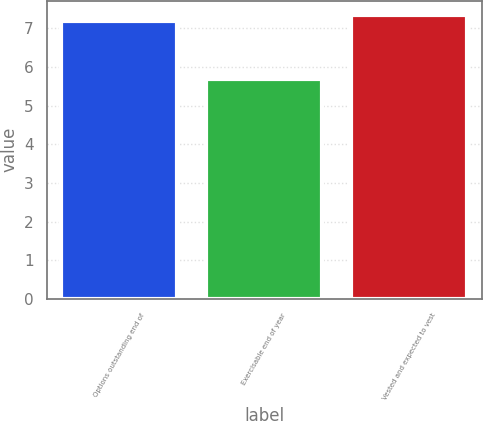Convert chart to OTSL. <chart><loc_0><loc_0><loc_500><loc_500><bar_chart><fcel>Options outstanding end of<fcel>Exercisable end of year<fcel>Vested and expected to vest<nl><fcel>7.2<fcel>5.7<fcel>7.35<nl></chart> 